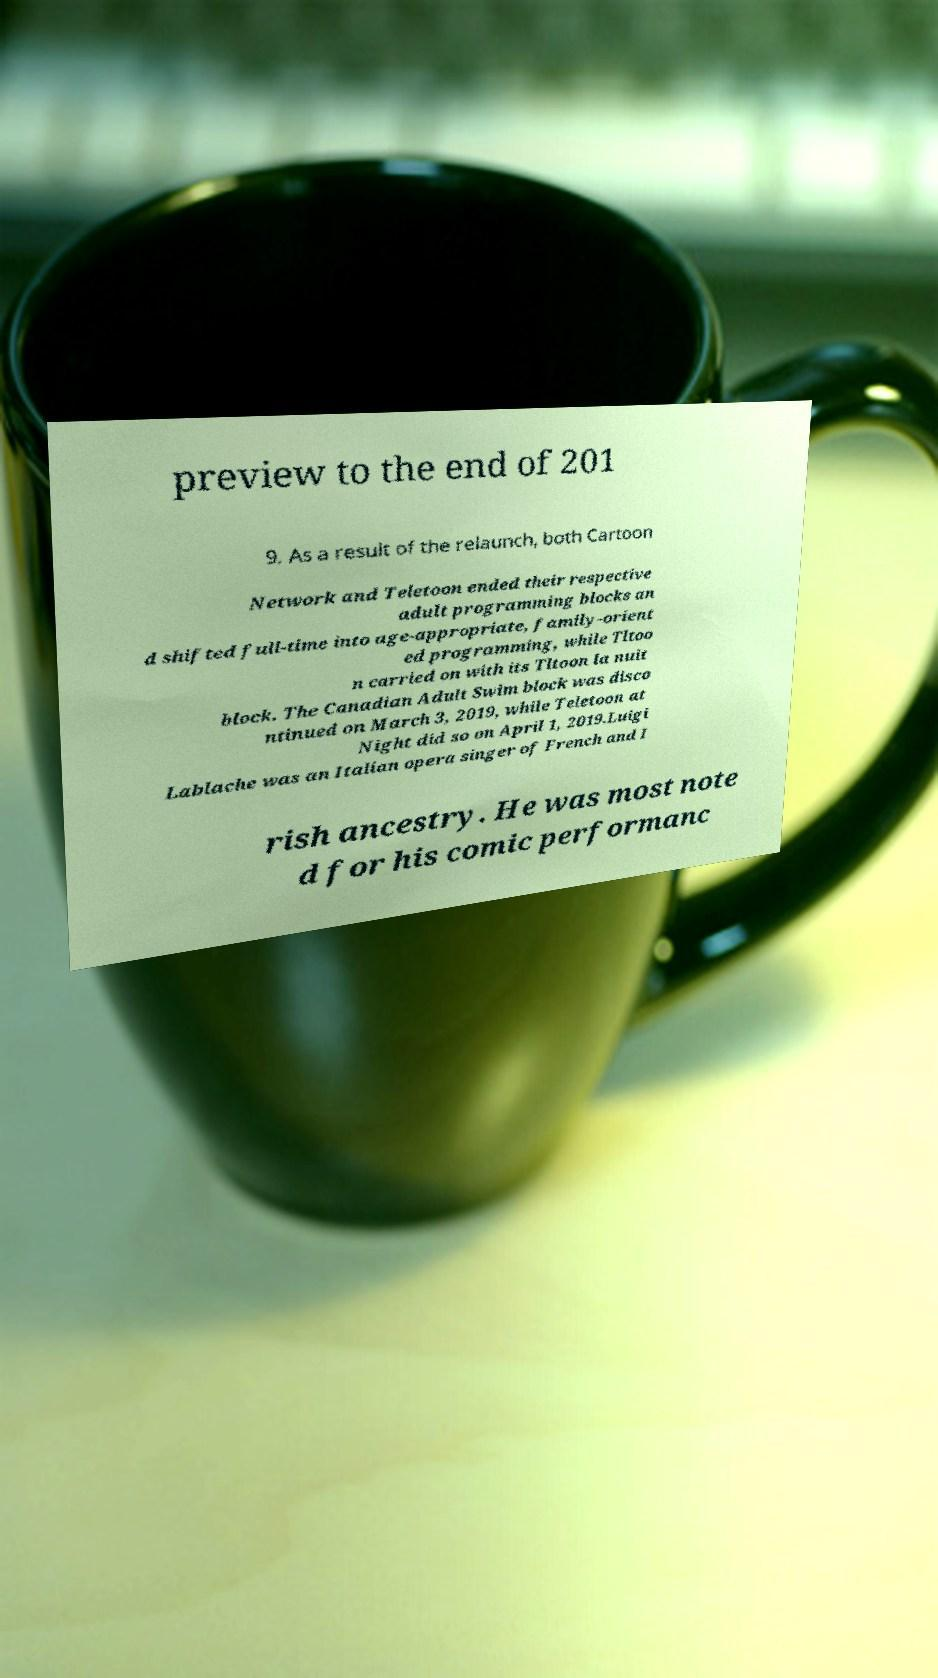Please identify and transcribe the text found in this image. preview to the end of 201 9. As a result of the relaunch, both Cartoon Network and Teletoon ended their respective adult programming blocks an d shifted full-time into age-appropriate, family-orient ed programming, while Tltoo n carried on with its Tltoon la nuit block. The Canadian Adult Swim block was disco ntinued on March 3, 2019, while Teletoon at Night did so on April 1, 2019.Luigi Lablache was an Italian opera singer of French and I rish ancestry. He was most note d for his comic performanc 